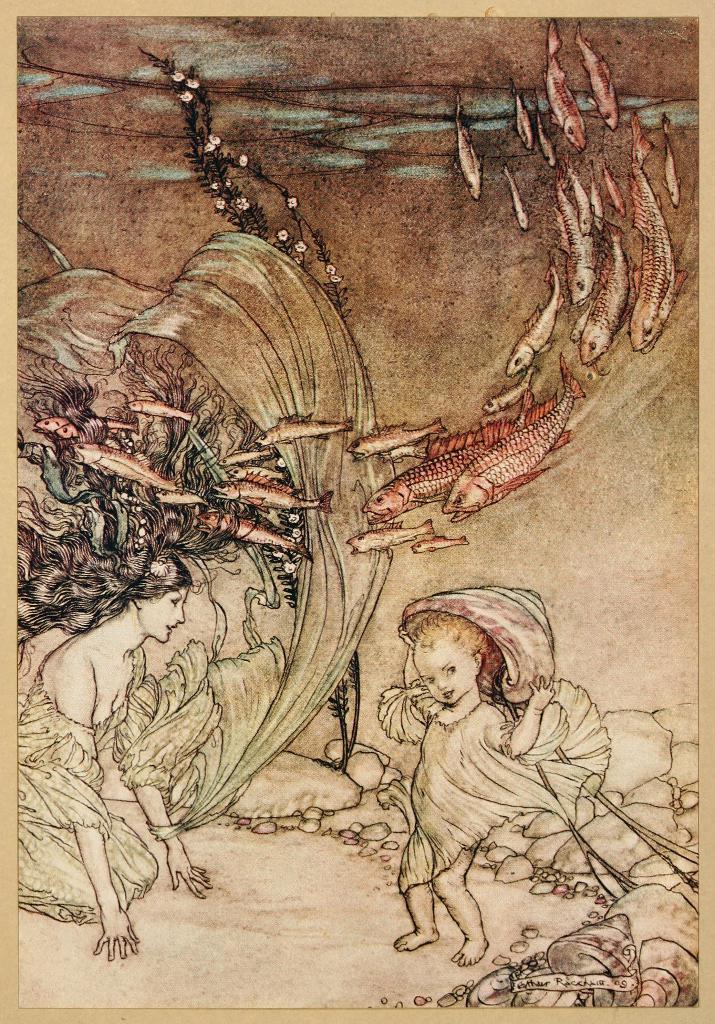Describe this image in one or two sentences. In this picture, it looks like a paper and on the paper there are drawings of two people, fishes and rocks. 